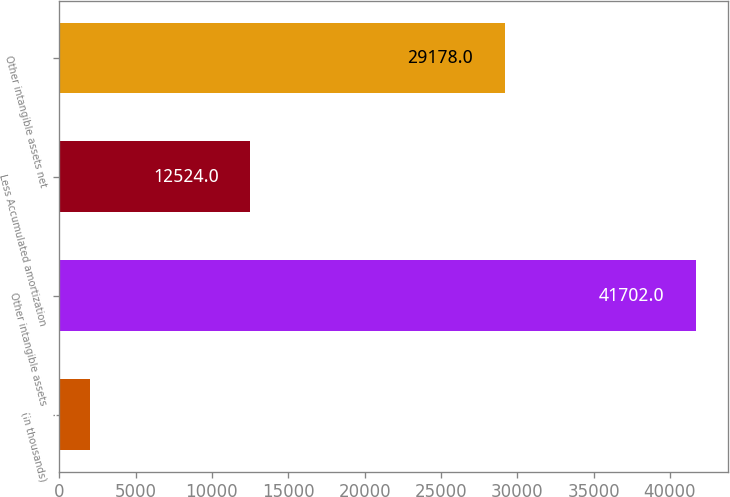<chart> <loc_0><loc_0><loc_500><loc_500><bar_chart><fcel>(in thousands)<fcel>Other intangible assets<fcel>Less Accumulated amortization<fcel>Other intangible assets net<nl><fcel>2011<fcel>41702<fcel>12524<fcel>29178<nl></chart> 